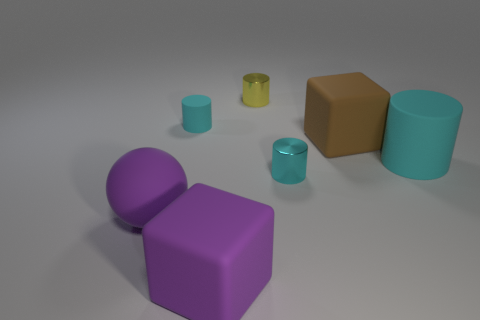There is a ball that is the same size as the brown rubber cube; what is its material?
Provide a succinct answer. Rubber. There is a yellow metallic thing left of the small cyan shiny cylinder; what is its shape?
Your response must be concise. Cylinder. What number of big cyan rubber things are the same shape as the small yellow thing?
Give a very brief answer. 1. Are there the same number of small metal objects behind the brown object and purple balls that are behind the big sphere?
Make the answer very short. No. Are there any large purple things made of the same material as the large sphere?
Give a very brief answer. Yes. Are the brown thing and the small yellow cylinder made of the same material?
Ensure brevity in your answer.  No. What number of green objects are small cylinders or large rubber blocks?
Your answer should be compact. 0. Are there more brown things behind the large cyan matte cylinder than tiny gray rubber objects?
Make the answer very short. Yes. Are there any things that have the same color as the matte sphere?
Your answer should be compact. Yes. What size is the yellow thing?
Ensure brevity in your answer.  Small. 